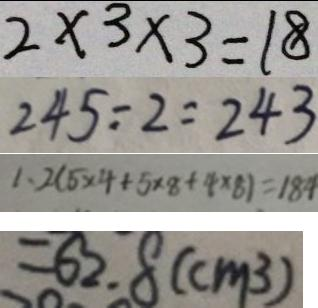Convert formula to latex. <formula><loc_0><loc_0><loc_500><loc_500>2 \times 3 \times 3 = 1 8 
 2 4 5 . - 2 = 2 4 3 
 1 、 2 ( 5 \times 4 + 5 \times 8 + 4 \times 8 ) = 1 8 4 
 = 6 2 . 8 ( c m ^ { 3 } )</formula> 